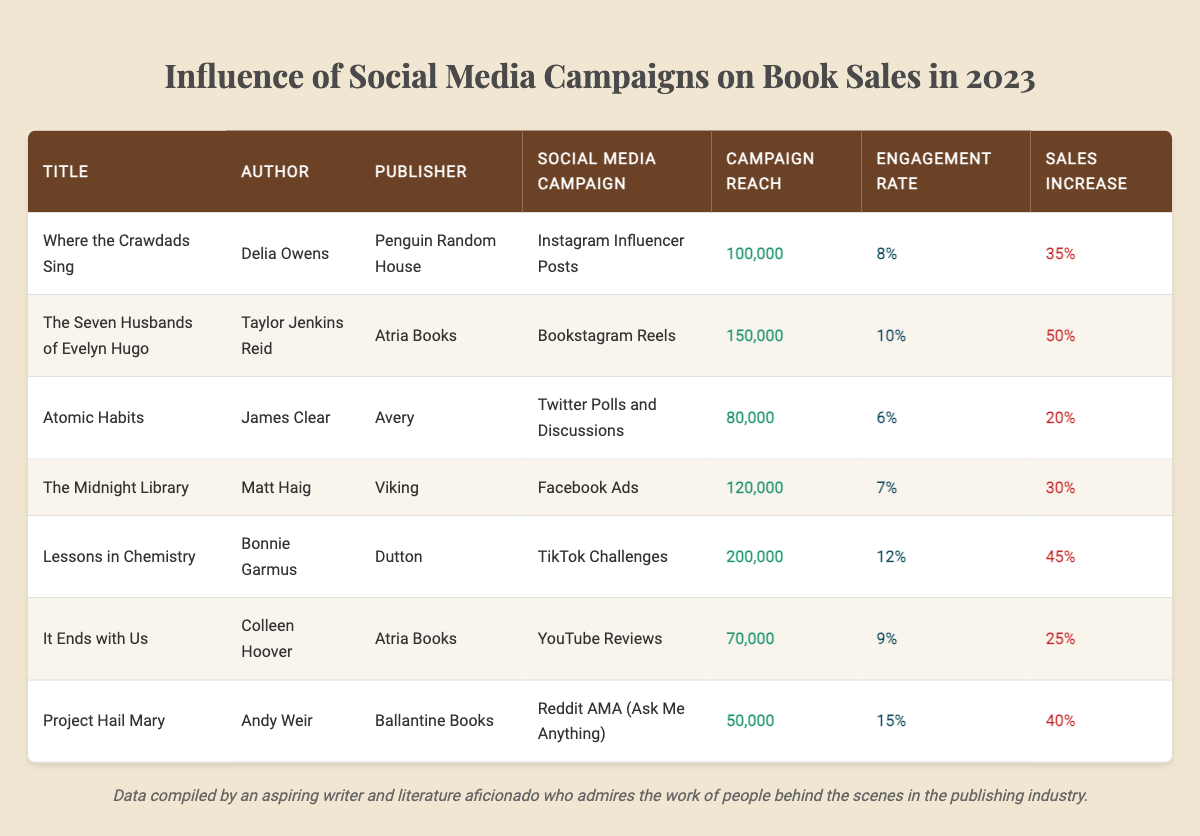What is the title of the book with the highest sales increase? Looking at the "Sales Increase" column, "The Seven Husbands of Evelyn Hugo" has a sales increase of 50%, which is the highest among all the books listed.
Answer: The Seven Husbands of Evelyn Hugo Which author is associated with TikTok Challenges? By checking the "Social Media Campaign" column for "TikTok Challenges," we find it is associated with the author Bonnie Garmus.
Answer: Bonnie Garmus What is the campaign reach for "Atomic Habits"? In the "Campaign Reach" column, the value for "Atomic Habits" is listed as 80,000.
Answer: 80,000 How many books had a campaign engagement rate of 10% or more? We can count the rows where the engagement rate is 10% or more; those books are "The Seven Husbands of Evelyn Hugo," "Lessons in Chemistry," and "Project Hail Mary." In total, there are 3.
Answer: 3 What is the average sales increase of the books listed? To find the average sales increase: convert the percentages to decimals (0.35, 0.50, 0.20, 0.30, 0.45, 0.25, 0.40), sum them up (0.35 + 0.50 + 0.20 + 0.30 + 0.45 + 0.25 + 0.40 = 2.45), and divide by the number of books (7). This gives an average of approximately 0.35 or 35%.
Answer: 35% Is there a book with both a high campaign reach and a low engagement rate? By examining the data, "Atomic Habits" has a campaign reach of 80,000 and an engagement rate of 6%, which is relatively low while still being notable in reach.
Answer: Yes What are the titles of the books published by Atria Books? Checking the "Publisher" column, both "The Seven Husbands of Evelyn Hugo" and "It Ends with Us" are published by Atria Books.
Answer: The Seven Husbands of Evelyn Hugo, It Ends with Us Which social media campaign yielded the highest engagement rate? Evaluating the "Engagement Rate" column, the highest rate is from "Project Hail Mary" with a rate of 15%.
Answer: Project Hail Mary What is the difference in campaign reach between the book with the highest and lowest reach? The highest campaign reach is for "Lessons in Chemistry" at 200,000 and the lowest is "Project Hail Mary" at 50,000. The difference is 200,000 - 50,000 = 150,000.
Answer: 150,000 